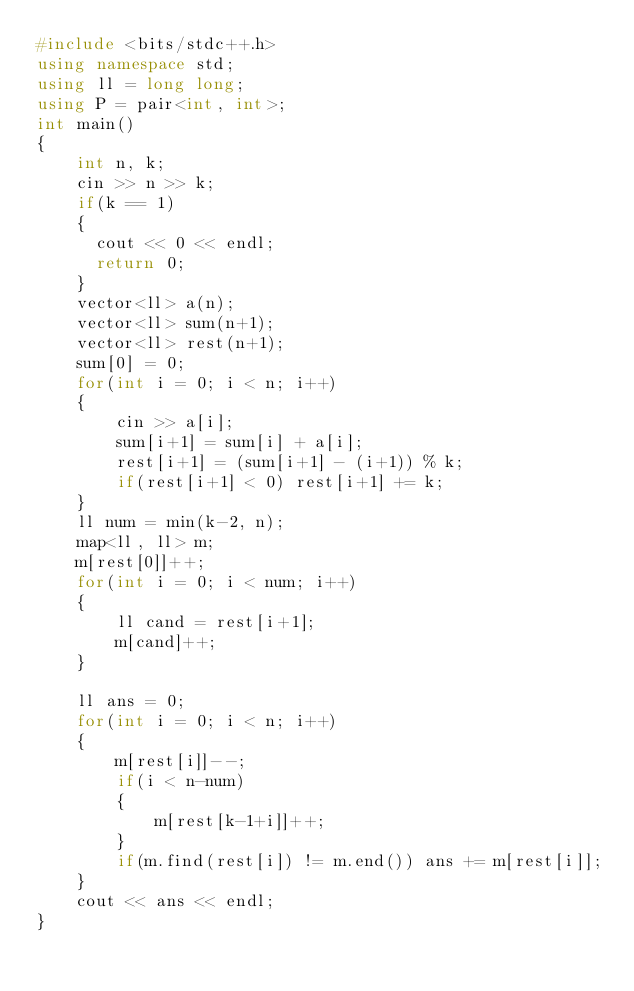<code> <loc_0><loc_0><loc_500><loc_500><_C++_>#include <bits/stdc++.h>
using namespace std;
using ll = long long;
using P = pair<int, int>;
int main()
{
    int n, k;
    cin >> n >> k;
    if(k == 1)
    {
      cout << 0 << endl;
      return 0;
    }
    vector<ll> a(n);
    vector<ll> sum(n+1);
    vector<ll> rest(n+1);
    sum[0] = 0;
    for(int i = 0; i < n; i++)
    {
        cin >> a[i];
        sum[i+1] = sum[i] + a[i];
        rest[i+1] = (sum[i+1] - (i+1)) % k;
        if(rest[i+1] < 0) rest[i+1] += k;
    }
    ll num = min(k-2, n);
    map<ll, ll> m;
    m[rest[0]]++;
    for(int i = 0; i < num; i++)
    {
        ll cand = rest[i+1];
        m[cand]++;
    }

    ll ans = 0;
    for(int i = 0; i < n; i++)
    {
        m[rest[i]]--;
        if(i < n-num)
        {
            m[rest[k-1+i]]++;
        }
        if(m.find(rest[i]) != m.end()) ans += m[rest[i]];
    }
    cout << ans << endl;
}
</code> 